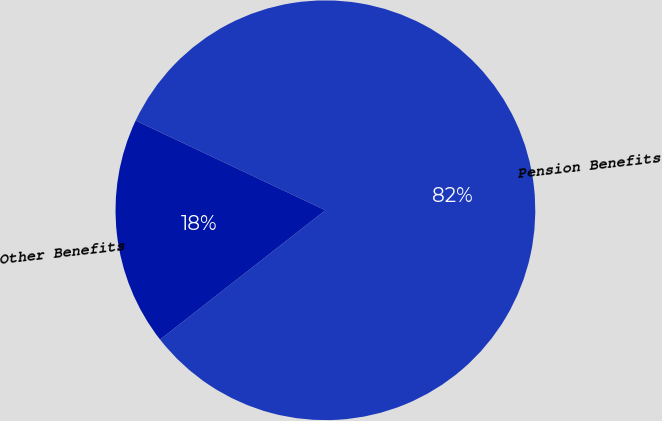Convert chart. <chart><loc_0><loc_0><loc_500><loc_500><pie_chart><fcel>Pension Benefits<fcel>Other Benefits<nl><fcel>82.41%<fcel>17.59%<nl></chart> 